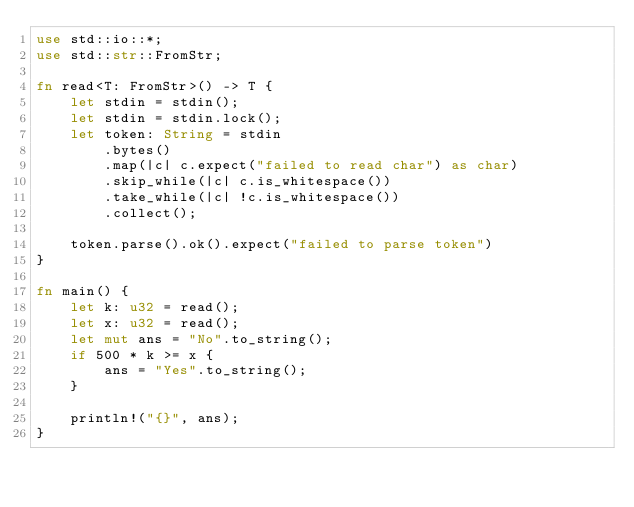Convert code to text. <code><loc_0><loc_0><loc_500><loc_500><_Rust_>use std::io::*;
use std::str::FromStr;

fn read<T: FromStr>() -> T {
    let stdin = stdin();
    let stdin = stdin.lock();
    let token: String = stdin
        .bytes()
        .map(|c| c.expect("failed to read char") as char)
        .skip_while(|c| c.is_whitespace())
        .take_while(|c| !c.is_whitespace())
        .collect();

    token.parse().ok().expect("failed to parse token")
}

fn main() {
    let k: u32 = read();
    let x: u32 = read();
    let mut ans = "No".to_string();
    if 500 * k >= x {
        ans = "Yes".to_string();
    }

    println!("{}", ans);
}
</code> 